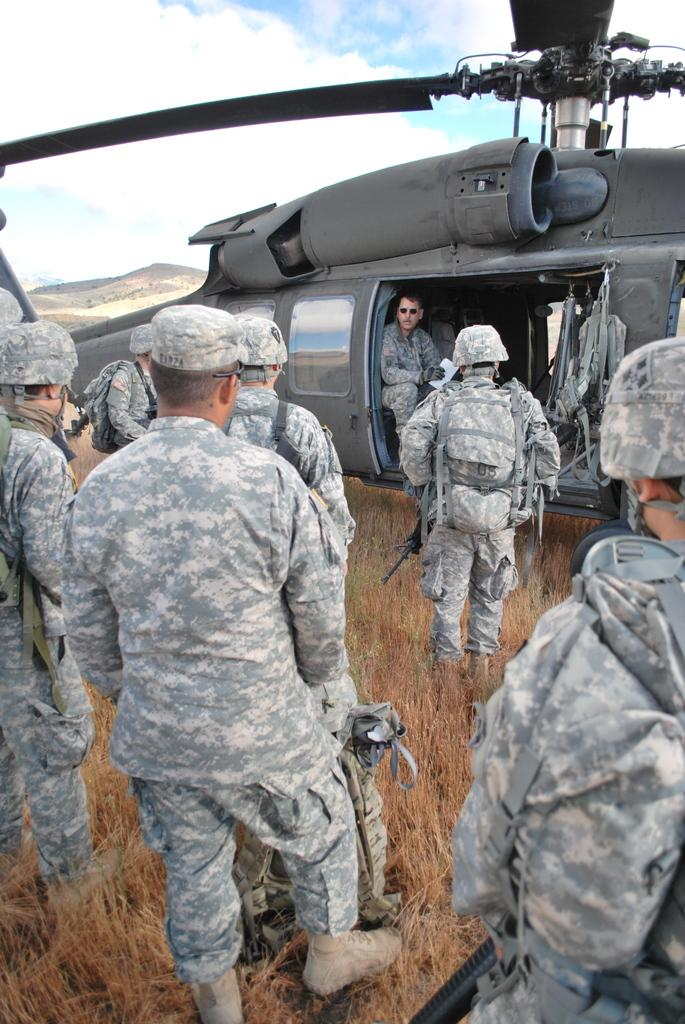What are the people in the image wearing? The people in the image are wearing army dress. What can be seen in the image besides the people? There is a plane, grass, and the sky visible in the image. What is the condition of the sky in the image? The sky is visible in the image, and clouds are present. Where is the drawer located in the image? There is no drawer present in the image. What type of poison is being used by the people in the image? There is no mention of poison in the image; the people are wearing army dress. 